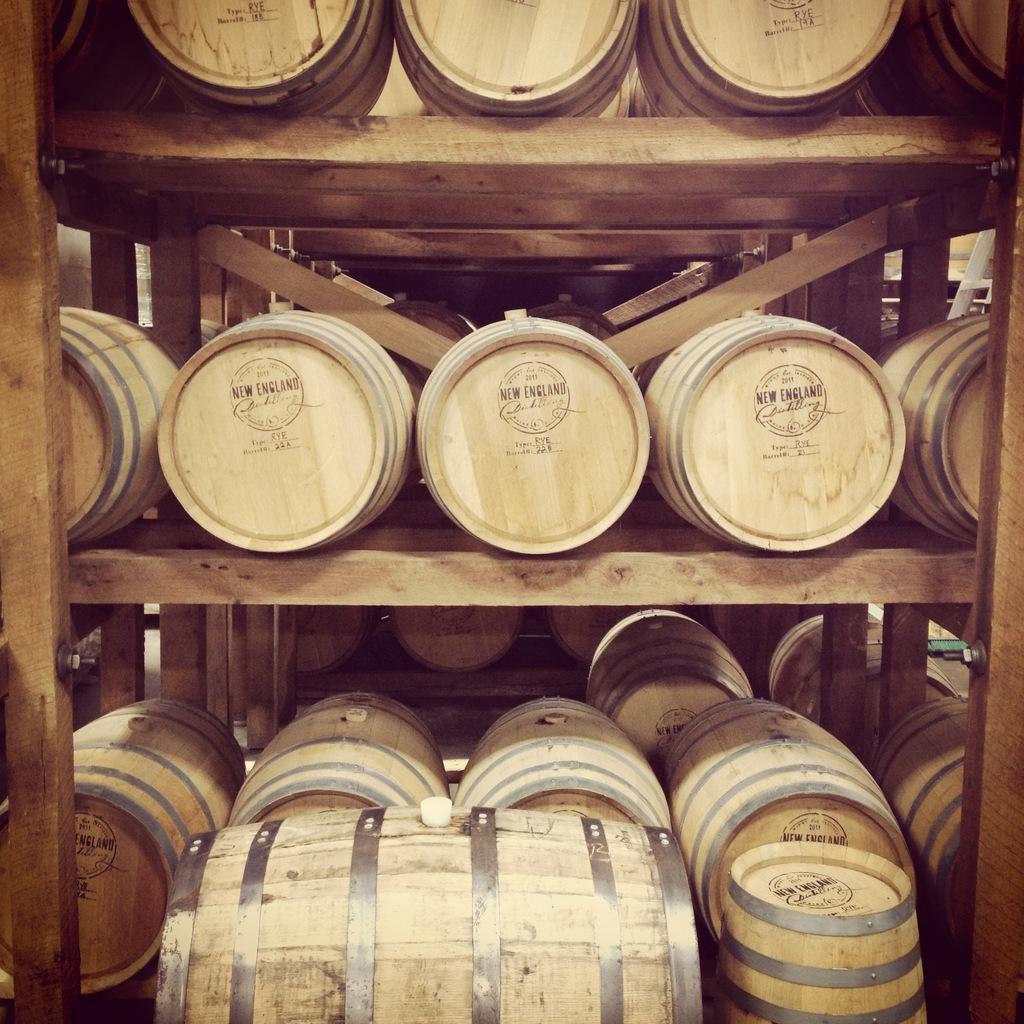Describe this image in one or two sentences. In the image we can see there are barrels kept in the wooden racks. 